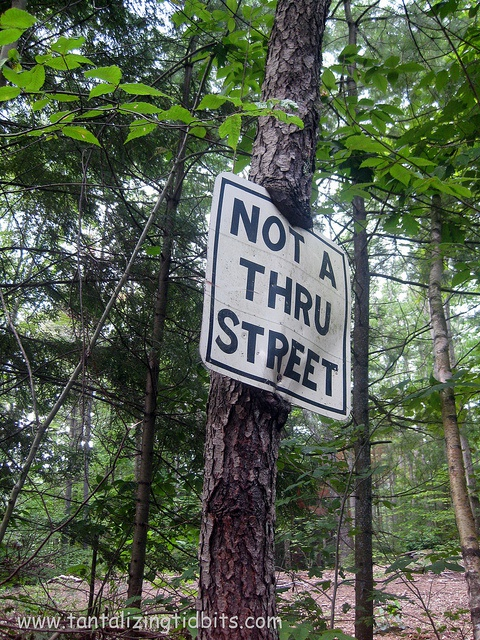Describe the objects in this image and their specific colors. I can see various objects in this image with different colors. 